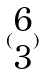<formula> <loc_0><loc_0><loc_500><loc_500>( \begin{matrix} 6 \\ 3 \end{matrix} )</formula> 